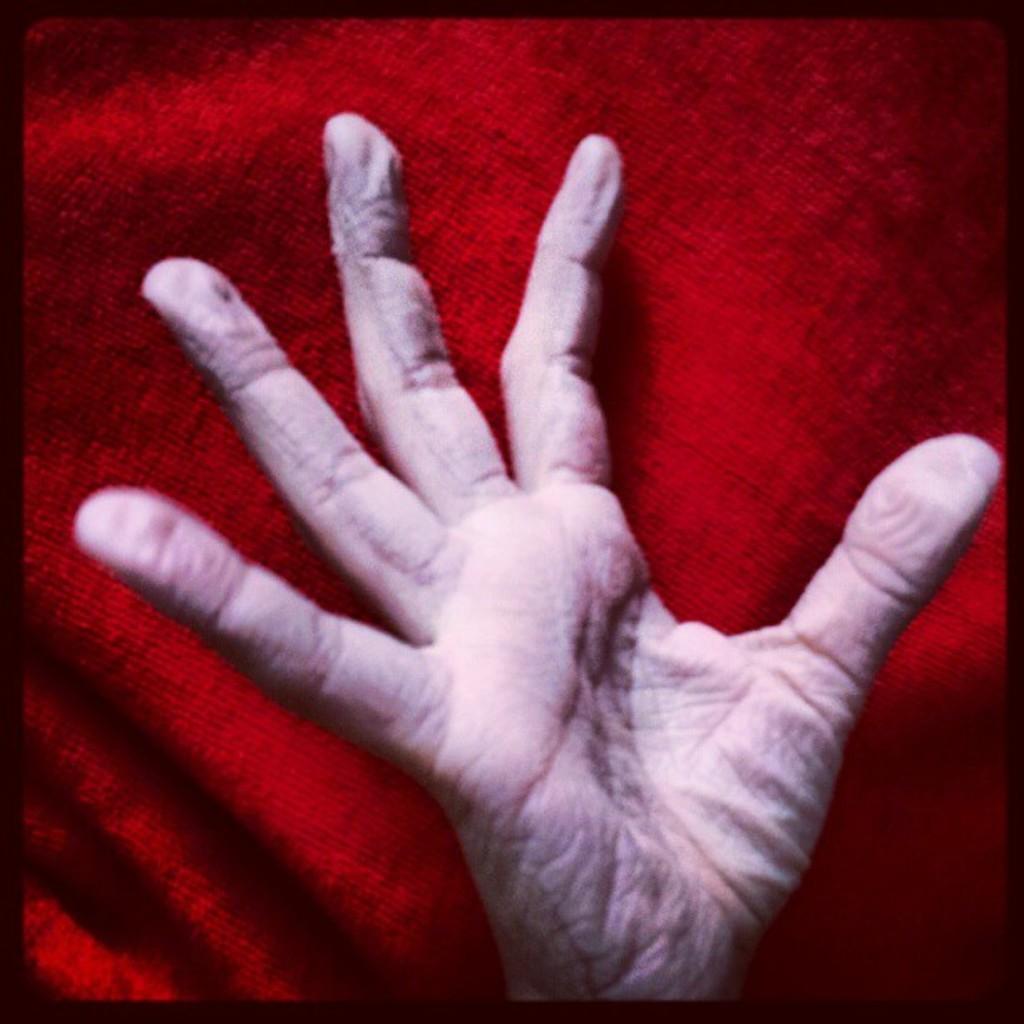What part of a person's body is visible in the image? There is a person's hand in the image. What color is the cloth that can be seen in the image? There is a red color cloth in the image. What scent can be detected from the person's hand in the image? There is no information about the scent of the person's hand in the image. How many friends are present with the person in the image? The image only shows a person's hand and a red color cloth, so there is no information about friends being present. 